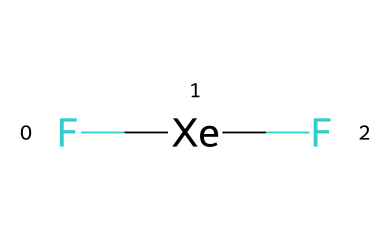What is the molecular formula of this compound? The molecular formula can be determined by identifying the elements present in the structure. In the provided SMILES representation, "F[Xe]F" shows fluorine (F) and xenon (Xe). There are two fluorine atoms and one xenon atom, leading to the molecular formula XeF2.
Answer: XeF2 How many bonds are there in xenon difluoride? To find the number of bonds, look at the connections between the atoms. The SMILES representation indicates that fluorine atoms are bonded to xenon: "F[Xe]F" signifies two F-Xe single covalent bonds. Thus, there are a total of 2 bonds in xenon difluoride.
Answer: 2 What is the hybridization of the xenon atom in this compound? To determine the hybridization, consider the steric number around the xenon atom. Xenon is bonded to two fluorine atoms and has three lone pairs of electrons. This results in a total steric number of 5, indicating sp3d hybridization.
Answer: sp3d Is xenon difluoride a polar molecule? A polar molecule has an uneven distribution of charge due to its molecular geometry. In xenon difluoride, despite the high electronegativity difference between xenon and fluorine, the symmetrical arrangement of the F atoms around xenon leads to a nonpolar nature. Therefore, it is not polar.
Answer: no What type of bond is present between xenon and fluorine in this compound? The bond type can be identified based on the electronegativity difference between the bonded atoms. The bond formed between xenon and fluorine is a covalent bond, as both elements share electrons to achieve stability.
Answer: covalent How many lone pairs are there on the xenon atom in xenon difluoride? The lone pairs can be counted based on the bonding situation of the xenon atom. In xenon difluoride, there are two bonds with fluorine and three lone pairs remaining on the xenon atom, which is calculated using its valence electrons.
Answer: 3 